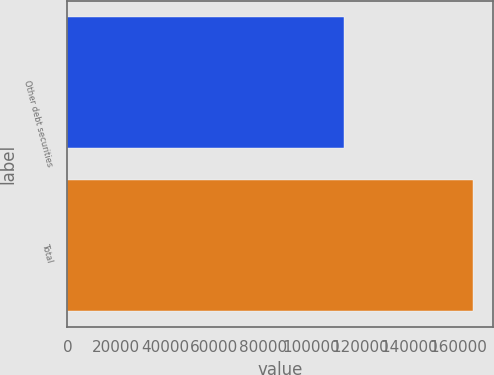<chart> <loc_0><loc_0><loc_500><loc_500><bar_chart><fcel>Other debt securities<fcel>Total<nl><fcel>113127<fcel>165943<nl></chart> 